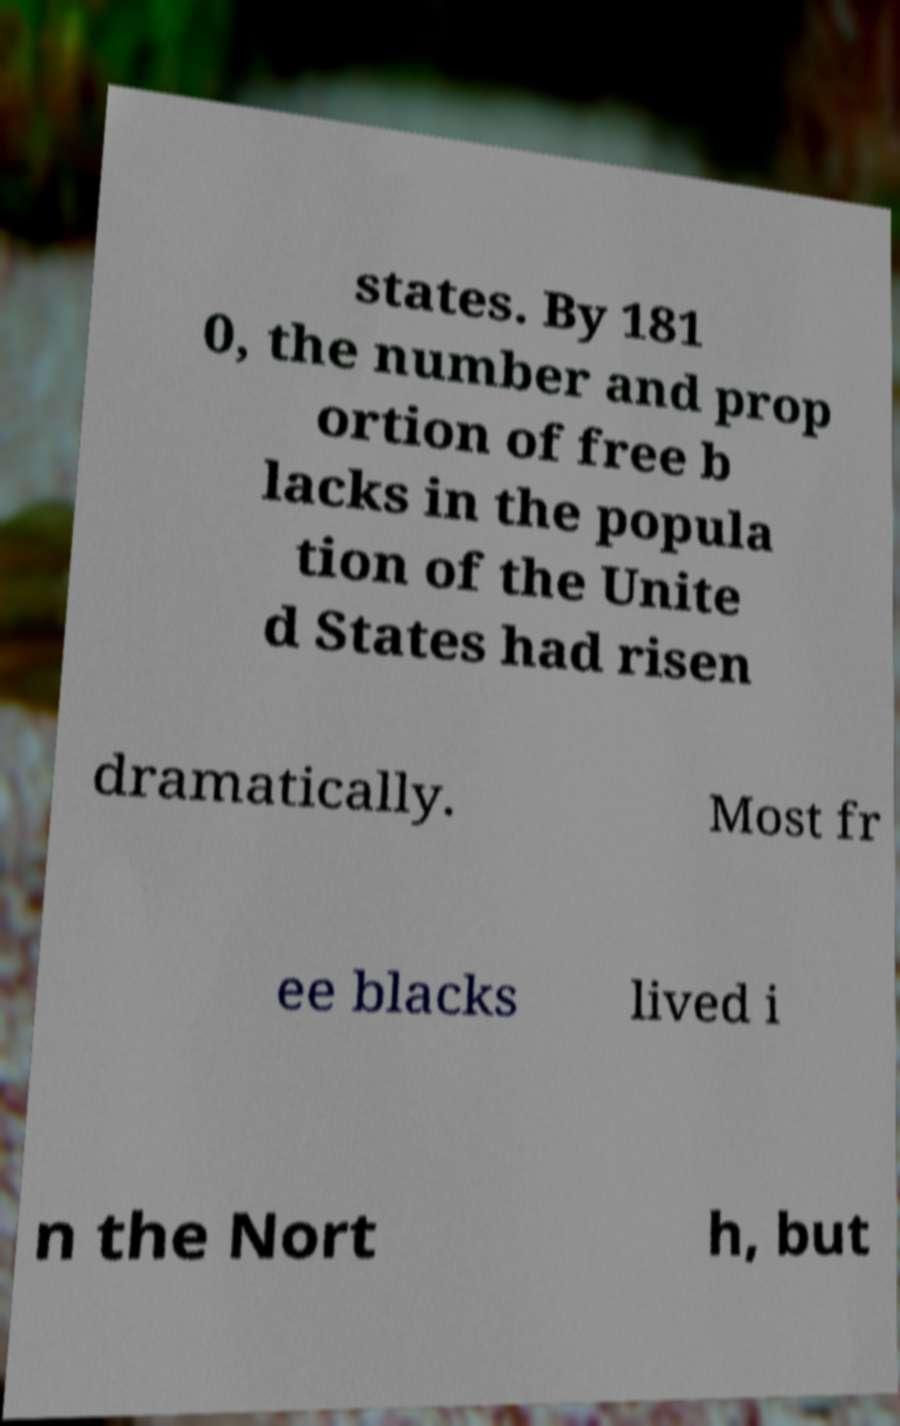Please read and relay the text visible in this image. What does it say? states. By 181 0, the number and prop ortion of free b lacks in the popula tion of the Unite d States had risen dramatically. Most fr ee blacks lived i n the Nort h, but 